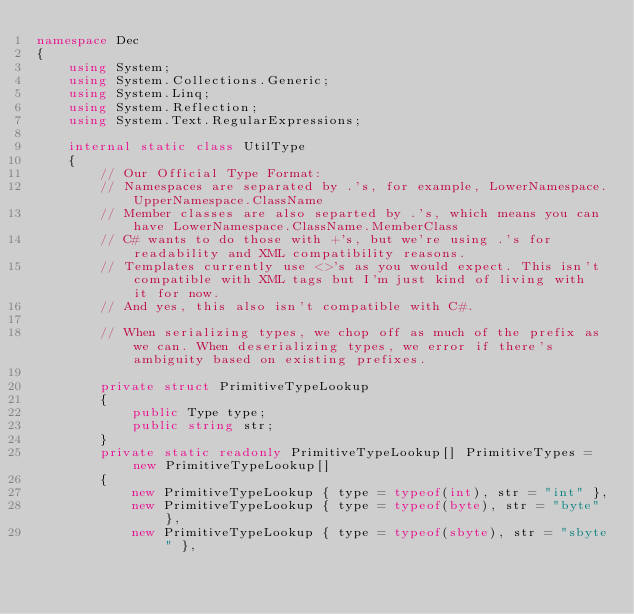Convert code to text. <code><loc_0><loc_0><loc_500><loc_500><_C#_>namespace Dec
{
    using System;
    using System.Collections.Generic;
    using System.Linq;
    using System.Reflection;
    using System.Text.RegularExpressions;

    internal static class UtilType
    {
        // Our Official Type Format:
        // Namespaces are separated by .'s, for example, LowerNamespace.UpperNamespace.ClassName
        // Member classes are also separted by .'s, which means you can have LowerNamespace.ClassName.MemberClass
        // C# wants to do those with +'s, but we're using .'s for readability and XML compatibility reasons.
        // Templates currently use <>'s as you would expect. This isn't compatible with XML tags but I'm just kind of living with it for now.
        // And yes, this also isn't compatible with C#.

        // When serializing types, we chop off as much of the prefix as we can. When deserializing types, we error if there's ambiguity based on existing prefixes.

        private struct PrimitiveTypeLookup
        {
            public Type type;
            public string str;
        }
        private static readonly PrimitiveTypeLookup[] PrimitiveTypes = new PrimitiveTypeLookup[]
        {
            new PrimitiveTypeLookup { type = typeof(int), str = "int" },
            new PrimitiveTypeLookup { type = typeof(byte), str = "byte" },
            new PrimitiveTypeLookup { type = typeof(sbyte), str = "sbyte" },</code> 